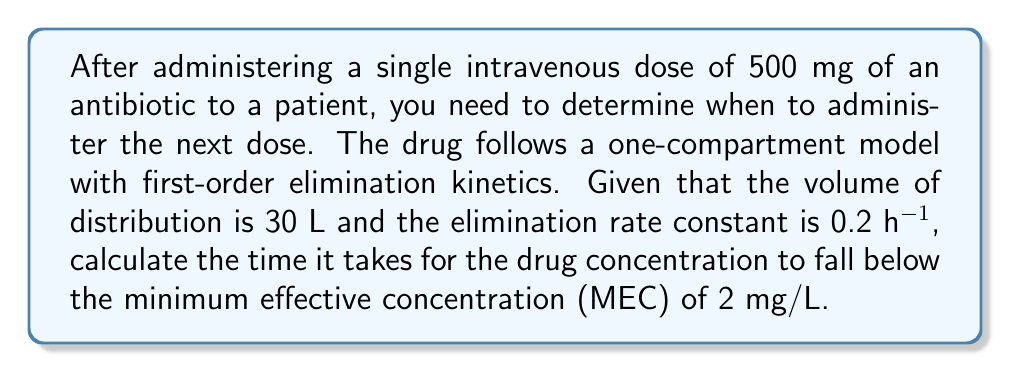What is the answer to this math problem? Let's approach this step-by-step:

1) First, we need to calculate the initial concentration (C₀) of the drug:
   $$C_0 = \frac{\text{Dose}}{\text{Volume of Distribution}} = \frac{500 \text{ mg}}{30 \text{ L}} = 16.67 \text{ mg/L}$$

2) The one-compartment model with first-order elimination follows the equation:
   $$C(t) = C_0 e^{-kt}$$
   where C(t) is the concentration at time t, C₀ is the initial concentration, k is the elimination rate constant, and t is time.

3) We want to find t when C(t) = MEC = 2 mg/L. Substituting into the equation:
   $$2 = 16.67 e^{-0.2t}$$

4) Taking natural logarithm of both sides:
   $$\ln(2) = \ln(16.67) - 0.2t$$

5) Solving for t:
   $$0.2t = \ln(16.67) - \ln(2)$$
   $$t = \frac{\ln(16.67) - \ln(2)}{0.2}$$

6) Calculating the result:
   $$t = \frac{2.814 - 0.693}{0.2} = 10.605 \text{ hours}$$

Therefore, it will take approximately 10.61 hours for the drug concentration to fall below the MEC of 2 mg/L.
Answer: 10.61 hours 